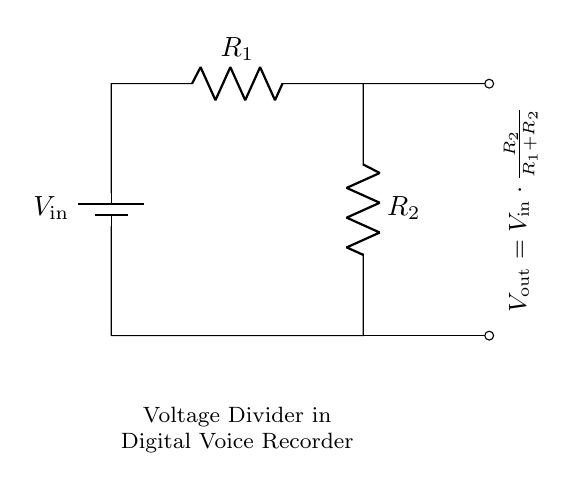What are the two resistors in the circuit? The circuit consists of two resistors, labeled R1 and R2, which are connected in series. They are part of the voltage divider configuration.
Answer: R1, R2 What is the formula for the output voltage? The output voltage is calculated using the formula shown in the circuit: Vout = Vin * (R2 / (R1 + R2)), indicating how Vout relates to Vin and the resistor values.
Answer: Vout = Vin * (R2 / (R1 + R2)) If R1 is twice the resistance of R2, what happens to Vout? If R1 is twice R2, the formula simplifies to Vout = Vin * (1/3), meaning the output voltage will be one-third of the input voltage.
Answer: One third of Vin What is the role of the voltage divider in the digital voice recorder? The voltage divider serves to reduce the input voltage to a suitable level for the internal circuits of the digital voice recorder, ensuring proper operation without overloading components.
Answer: Reduce input voltage What happens if R2 is eliminated from the circuit? Eliminating R2 would mean that the voltage divider configuration is lost. The circuit would effectively become a direct connection to the input voltage, allowing for no voltage reduction and potentially damage sensitive components.
Answer: No voltage reduction What is the purpose of the battery in the circuit? The battery provides the input voltage needed to power the circuit, supplying the necessary current to determine the output voltage across the resistors in the divider.
Answer: Supply input voltage 